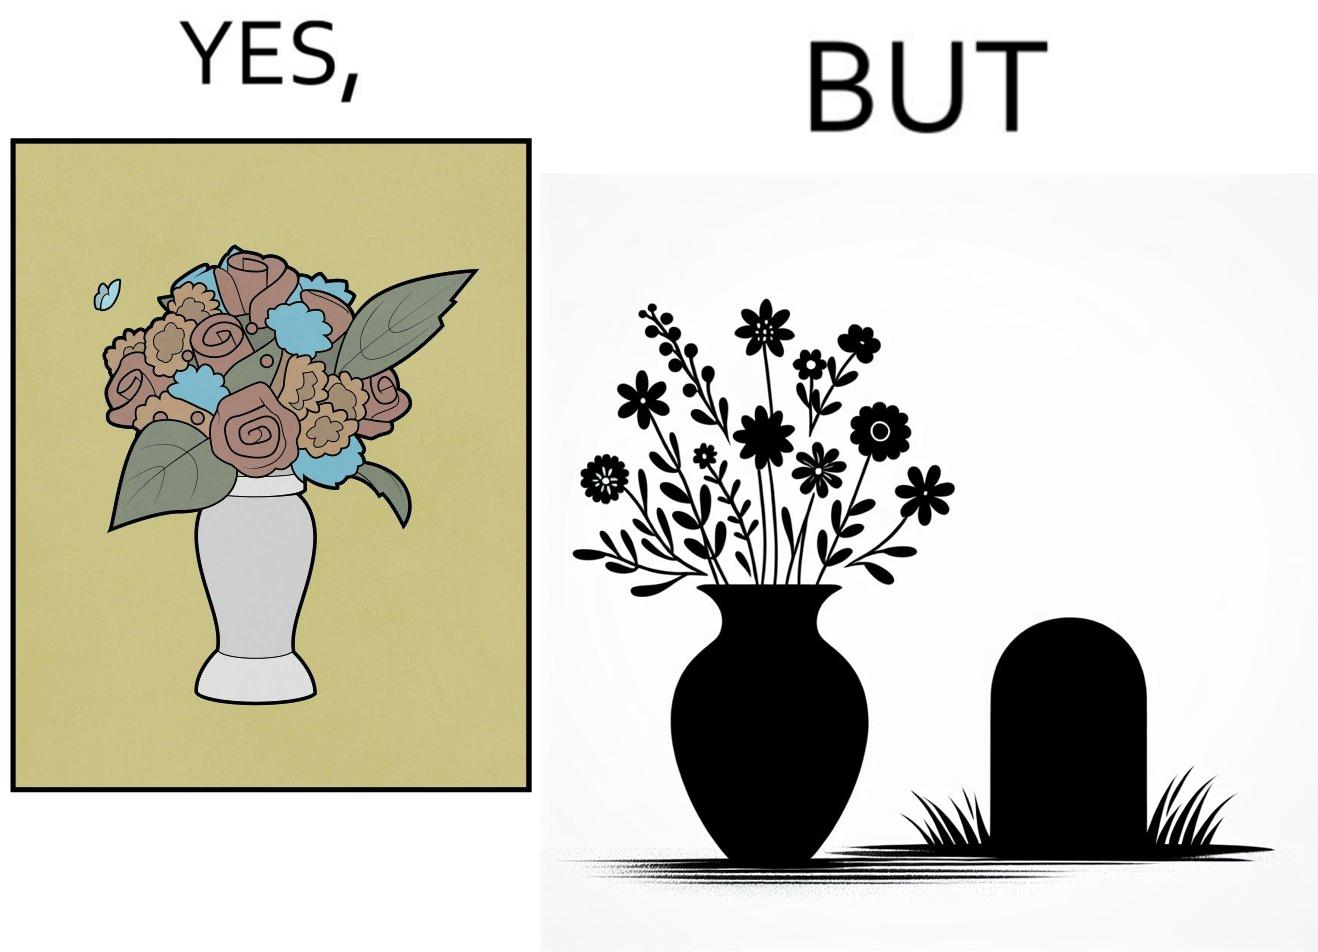Describe the contrast between the left and right parts of this image. In the left part of the image: a beautiful vase of full of different beautiful flowers In the right part of the image: a beautiful vase of full of different beautiful flowers put in front of someone's grave stone 